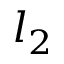<formula> <loc_0><loc_0><loc_500><loc_500>l _ { 2 }</formula> 